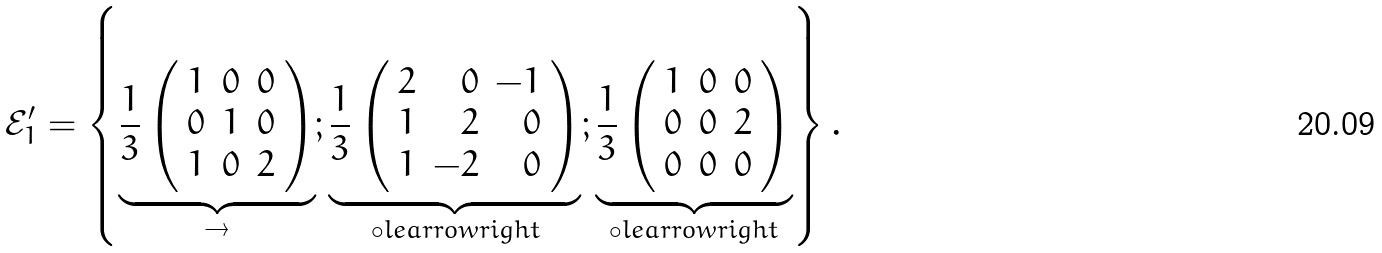Convert formula to latex. <formula><loc_0><loc_0><loc_500><loc_500>\mathcal { E } _ { 1 } ^ { \prime } = \left \{ \underbrace { \frac { 1 } { 3 } \left ( \begin{array} { r r r } 1 & 0 & 0 \\ 0 & 1 & 0 \\ 1 & 0 & 2 \\ \end{array} \right ) } _ { \rightarrow } ; \underbrace { \frac { 1 } { 3 } \left ( \begin{array} { r r r } 2 & 0 & - 1 \\ 1 & 2 & 0 \\ 1 & - 2 & 0 \\ \end{array} \right ) } _ { \circ l e a r r o w r i g h t } ; \underbrace { \frac { 1 } { 3 } \left ( \begin{array} { r r r } 1 & 0 & 0 \\ 0 & 0 & 2 \\ 0 & 0 & 0 \\ \end{array} \right ) } _ { \circ l e a r r o w r i g h t } \right \} .</formula> 